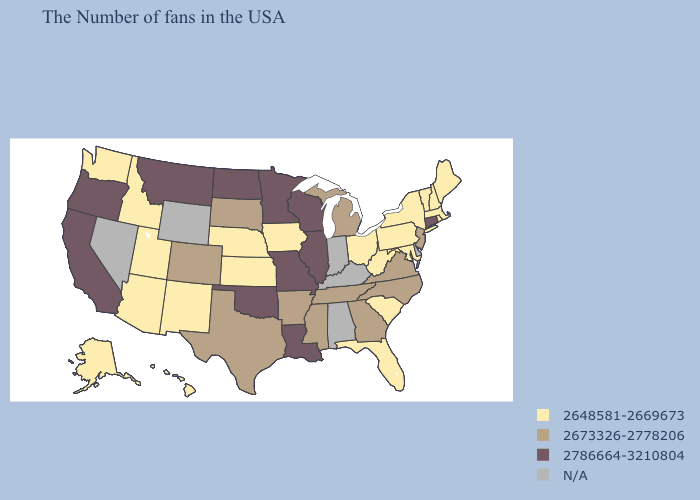Among the states that border Arizona , which have the highest value?
Give a very brief answer. California. Does Idaho have the highest value in the USA?
Answer briefly. No. Name the states that have a value in the range 2786664-3210804?
Keep it brief. Connecticut, Wisconsin, Illinois, Louisiana, Missouri, Minnesota, Oklahoma, North Dakota, Montana, California, Oregon. What is the lowest value in the USA?
Write a very short answer. 2648581-2669673. Name the states that have a value in the range 2786664-3210804?
Quick response, please. Connecticut, Wisconsin, Illinois, Louisiana, Missouri, Minnesota, Oklahoma, North Dakota, Montana, California, Oregon. What is the lowest value in the USA?
Quick response, please. 2648581-2669673. Which states have the lowest value in the MidWest?
Be succinct. Ohio, Iowa, Kansas, Nebraska. What is the highest value in the Northeast ?
Short answer required. 2786664-3210804. Among the states that border Arkansas , which have the lowest value?
Write a very short answer. Tennessee, Mississippi, Texas. Among the states that border Washington , does Oregon have the highest value?
Quick response, please. Yes. Name the states that have a value in the range N/A?
Answer briefly. Delaware, Kentucky, Indiana, Alabama, Wyoming, Nevada. What is the lowest value in the Northeast?
Be succinct. 2648581-2669673. Name the states that have a value in the range N/A?
Keep it brief. Delaware, Kentucky, Indiana, Alabama, Wyoming, Nevada. What is the value of Pennsylvania?
Give a very brief answer. 2648581-2669673. What is the value of South Carolina?
Keep it brief. 2648581-2669673. 